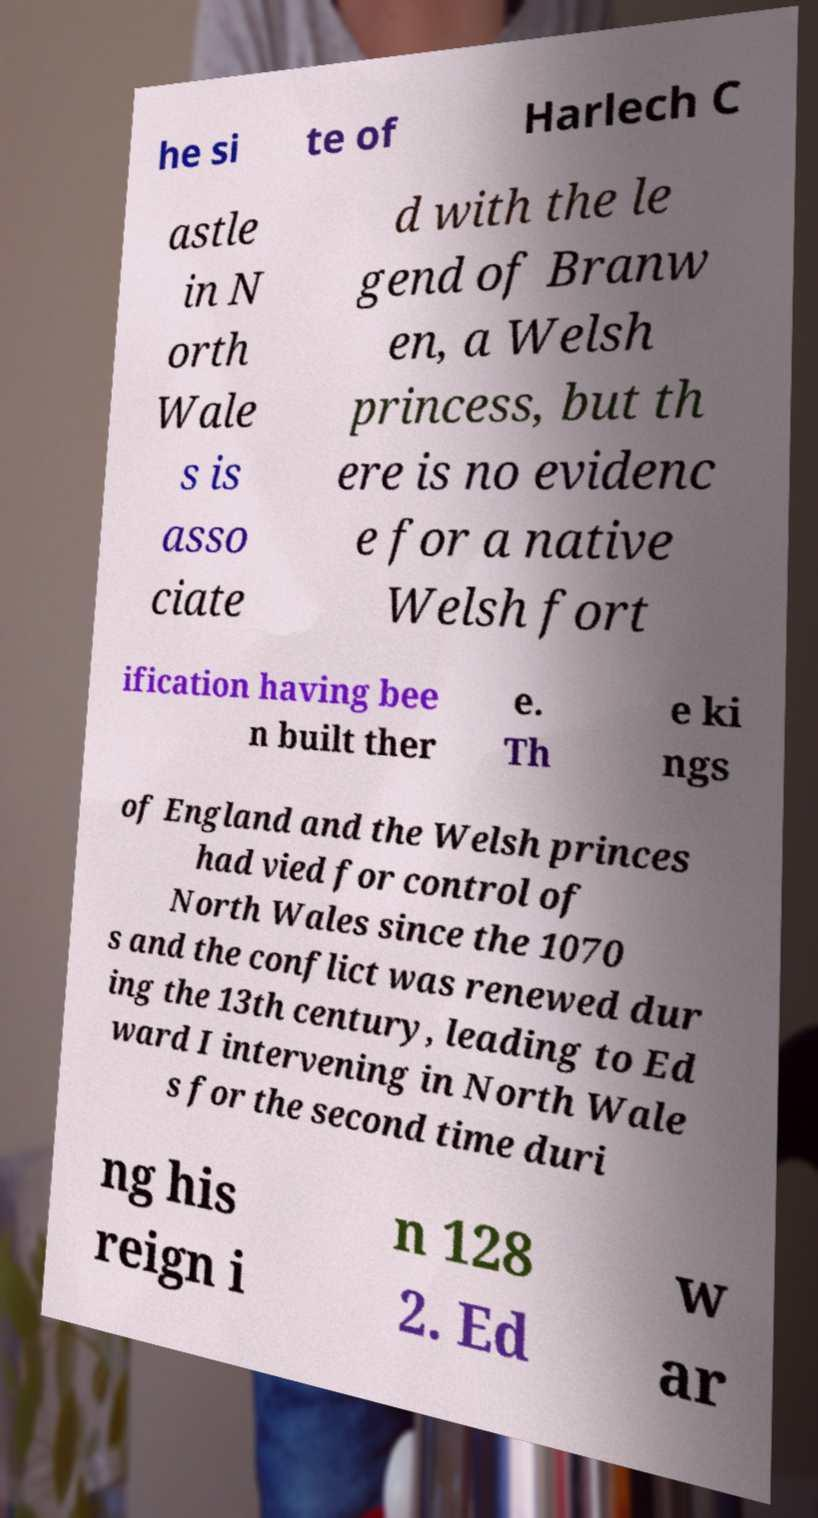Could you assist in decoding the text presented in this image and type it out clearly? he si te of Harlech C astle in N orth Wale s is asso ciate d with the le gend of Branw en, a Welsh princess, but th ere is no evidenc e for a native Welsh fort ification having bee n built ther e. Th e ki ngs of England and the Welsh princes had vied for control of North Wales since the 1070 s and the conflict was renewed dur ing the 13th century, leading to Ed ward I intervening in North Wale s for the second time duri ng his reign i n 128 2. Ed w ar 